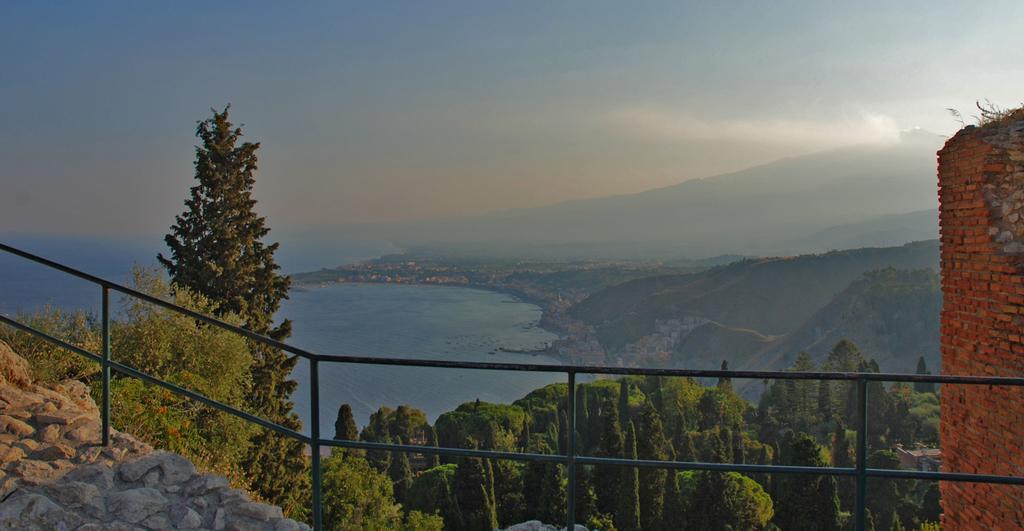In one or two sentences, can you explain what this image depicts? In this image we can see some trees and there is a fence and on the right side, we can see a brick wall. In the background, we can see water body and mountains and the sky. 